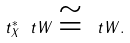<formula> <loc_0><loc_0><loc_500><loc_500>\ t _ { X } ^ { * } \ t W \cong \ t W .</formula> 